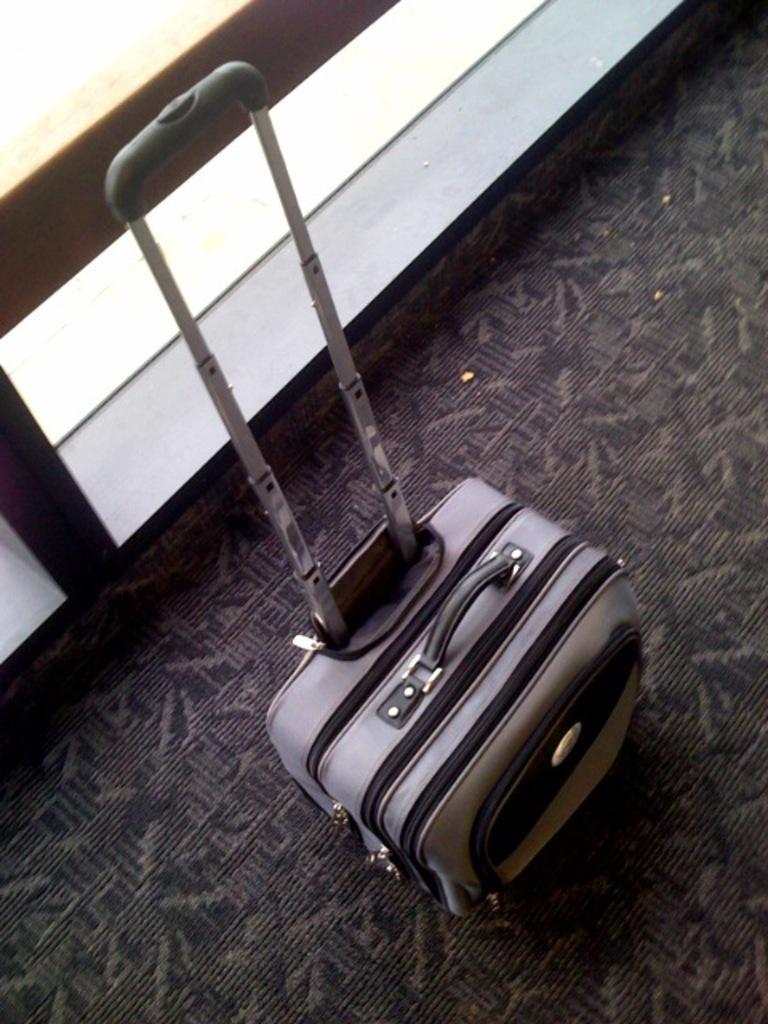How would you summarize this image in a sentence or two? A trolley luggage bag with its handle fully pulled is shown in the picture. 